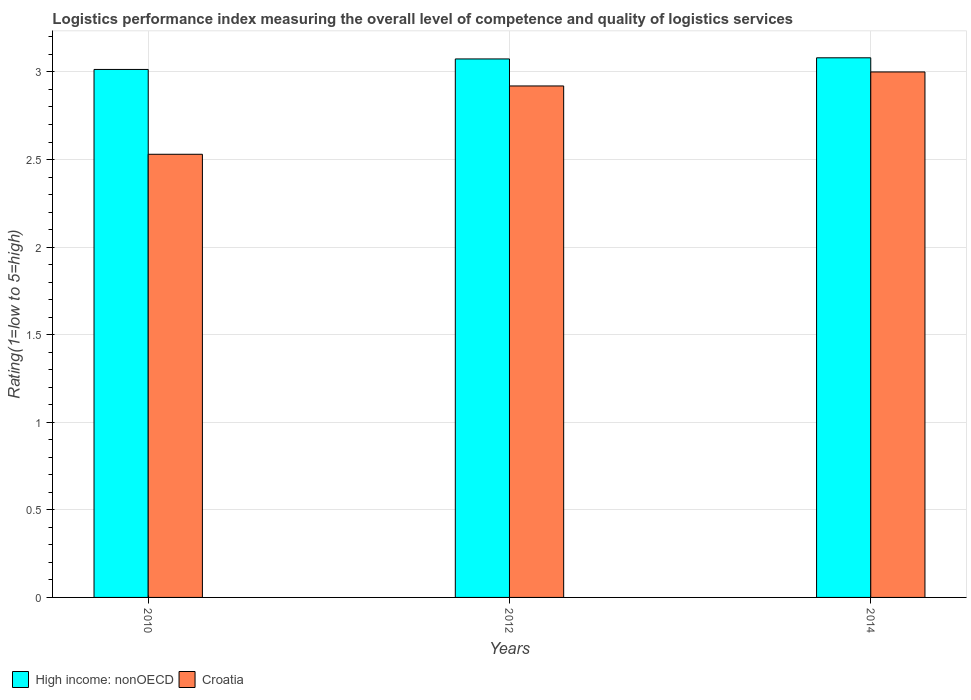Are the number of bars on each tick of the X-axis equal?
Give a very brief answer. Yes. What is the label of the 1st group of bars from the left?
Keep it short and to the point. 2010. In how many cases, is the number of bars for a given year not equal to the number of legend labels?
Offer a very short reply. 0. What is the Logistic performance index in High income: nonOECD in 2010?
Offer a very short reply. 3.01. Across all years, what is the maximum Logistic performance index in High income: nonOECD?
Ensure brevity in your answer.  3.08. Across all years, what is the minimum Logistic performance index in High income: nonOECD?
Offer a very short reply. 3.01. In which year was the Logistic performance index in Croatia maximum?
Provide a short and direct response. 2014. In which year was the Logistic performance index in Croatia minimum?
Provide a succinct answer. 2010. What is the total Logistic performance index in Croatia in the graph?
Provide a succinct answer. 8.45. What is the difference between the Logistic performance index in Croatia in 2010 and that in 2012?
Keep it short and to the point. -0.39. What is the difference between the Logistic performance index in Croatia in 2010 and the Logistic performance index in High income: nonOECD in 2012?
Provide a succinct answer. -0.54. What is the average Logistic performance index in Croatia per year?
Offer a terse response. 2.82. In the year 2010, what is the difference between the Logistic performance index in High income: nonOECD and Logistic performance index in Croatia?
Ensure brevity in your answer.  0.48. In how many years, is the Logistic performance index in Croatia greater than 2.3?
Your response must be concise. 3. What is the ratio of the Logistic performance index in Croatia in 2010 to that in 2012?
Offer a very short reply. 0.87. Is the difference between the Logistic performance index in High income: nonOECD in 2010 and 2012 greater than the difference between the Logistic performance index in Croatia in 2010 and 2012?
Your answer should be very brief. Yes. What is the difference between the highest and the second highest Logistic performance index in High income: nonOECD?
Give a very brief answer. 0.01. What is the difference between the highest and the lowest Logistic performance index in Croatia?
Offer a terse response. 0.47. In how many years, is the Logistic performance index in High income: nonOECD greater than the average Logistic performance index in High income: nonOECD taken over all years?
Provide a short and direct response. 2. Is the sum of the Logistic performance index in Croatia in 2012 and 2014 greater than the maximum Logistic performance index in High income: nonOECD across all years?
Your response must be concise. Yes. What does the 1st bar from the left in 2010 represents?
Offer a terse response. High income: nonOECD. What does the 2nd bar from the right in 2014 represents?
Your response must be concise. High income: nonOECD. Are all the bars in the graph horizontal?
Provide a succinct answer. No. What is the difference between two consecutive major ticks on the Y-axis?
Provide a short and direct response. 0.5. Are the values on the major ticks of Y-axis written in scientific E-notation?
Ensure brevity in your answer.  No. Where does the legend appear in the graph?
Make the answer very short. Bottom left. How many legend labels are there?
Your answer should be very brief. 2. What is the title of the graph?
Give a very brief answer. Logistics performance index measuring the overall level of competence and quality of logistics services. What is the label or title of the Y-axis?
Your response must be concise. Rating(1=low to 5=high). What is the Rating(1=low to 5=high) in High income: nonOECD in 2010?
Offer a terse response. 3.01. What is the Rating(1=low to 5=high) in Croatia in 2010?
Ensure brevity in your answer.  2.53. What is the Rating(1=low to 5=high) of High income: nonOECD in 2012?
Give a very brief answer. 3.07. What is the Rating(1=low to 5=high) of Croatia in 2012?
Provide a succinct answer. 2.92. What is the Rating(1=low to 5=high) of High income: nonOECD in 2014?
Make the answer very short. 3.08. What is the Rating(1=low to 5=high) in Croatia in 2014?
Offer a terse response. 3. Across all years, what is the maximum Rating(1=low to 5=high) in High income: nonOECD?
Keep it short and to the point. 3.08. Across all years, what is the minimum Rating(1=low to 5=high) in High income: nonOECD?
Ensure brevity in your answer.  3.01. Across all years, what is the minimum Rating(1=low to 5=high) of Croatia?
Ensure brevity in your answer.  2.53. What is the total Rating(1=low to 5=high) in High income: nonOECD in the graph?
Offer a terse response. 9.17. What is the total Rating(1=low to 5=high) of Croatia in the graph?
Ensure brevity in your answer.  8.45. What is the difference between the Rating(1=low to 5=high) in High income: nonOECD in 2010 and that in 2012?
Your response must be concise. -0.06. What is the difference between the Rating(1=low to 5=high) of Croatia in 2010 and that in 2012?
Offer a very short reply. -0.39. What is the difference between the Rating(1=low to 5=high) in High income: nonOECD in 2010 and that in 2014?
Offer a terse response. -0.07. What is the difference between the Rating(1=low to 5=high) of Croatia in 2010 and that in 2014?
Your answer should be very brief. -0.47. What is the difference between the Rating(1=low to 5=high) in High income: nonOECD in 2012 and that in 2014?
Provide a short and direct response. -0.01. What is the difference between the Rating(1=low to 5=high) in Croatia in 2012 and that in 2014?
Offer a terse response. -0.08. What is the difference between the Rating(1=low to 5=high) in High income: nonOECD in 2010 and the Rating(1=low to 5=high) in Croatia in 2012?
Provide a succinct answer. 0.09. What is the difference between the Rating(1=low to 5=high) of High income: nonOECD in 2010 and the Rating(1=low to 5=high) of Croatia in 2014?
Your answer should be very brief. 0.01. What is the difference between the Rating(1=low to 5=high) in High income: nonOECD in 2012 and the Rating(1=low to 5=high) in Croatia in 2014?
Ensure brevity in your answer.  0.07. What is the average Rating(1=low to 5=high) in High income: nonOECD per year?
Your answer should be very brief. 3.06. What is the average Rating(1=low to 5=high) of Croatia per year?
Keep it short and to the point. 2.82. In the year 2010, what is the difference between the Rating(1=low to 5=high) in High income: nonOECD and Rating(1=low to 5=high) in Croatia?
Make the answer very short. 0.48. In the year 2012, what is the difference between the Rating(1=low to 5=high) in High income: nonOECD and Rating(1=low to 5=high) in Croatia?
Make the answer very short. 0.15. In the year 2014, what is the difference between the Rating(1=low to 5=high) of High income: nonOECD and Rating(1=low to 5=high) of Croatia?
Offer a terse response. 0.08. What is the ratio of the Rating(1=low to 5=high) in High income: nonOECD in 2010 to that in 2012?
Your response must be concise. 0.98. What is the ratio of the Rating(1=low to 5=high) in Croatia in 2010 to that in 2012?
Ensure brevity in your answer.  0.87. What is the ratio of the Rating(1=low to 5=high) in High income: nonOECD in 2010 to that in 2014?
Your answer should be compact. 0.98. What is the ratio of the Rating(1=low to 5=high) of Croatia in 2010 to that in 2014?
Provide a succinct answer. 0.84. What is the ratio of the Rating(1=low to 5=high) in Croatia in 2012 to that in 2014?
Keep it short and to the point. 0.97. What is the difference between the highest and the second highest Rating(1=low to 5=high) of High income: nonOECD?
Give a very brief answer. 0.01. What is the difference between the highest and the lowest Rating(1=low to 5=high) of High income: nonOECD?
Provide a short and direct response. 0.07. What is the difference between the highest and the lowest Rating(1=low to 5=high) in Croatia?
Give a very brief answer. 0.47. 